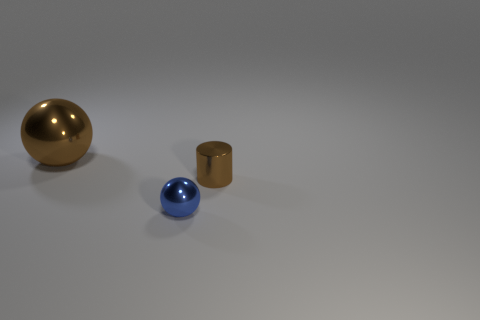Does the tiny metal cylinder have the same color as the large ball?
Your answer should be compact. Yes. What number of metal cylinders are behind the large brown metal object?
Make the answer very short. 0. How many metallic things are to the left of the cylinder and behind the tiny metallic ball?
Your answer should be very brief. 1. There is a tiny thing that is made of the same material as the small ball; what is its shape?
Make the answer very short. Cylinder. There is a brown sphere to the left of the cylinder; does it have the same size as the brown metal thing on the right side of the big brown thing?
Ensure brevity in your answer.  No. What is the color of the sphere that is in front of the brown sphere?
Provide a short and direct response. Blue. There is a object that is in front of the small object that is behind the blue metal ball; what is it made of?
Give a very brief answer. Metal. The blue shiny thing is what shape?
Ensure brevity in your answer.  Sphere. What material is the other thing that is the same shape as the tiny blue object?
Keep it short and to the point. Metal. What number of other metallic balls have the same size as the brown ball?
Keep it short and to the point. 0. 